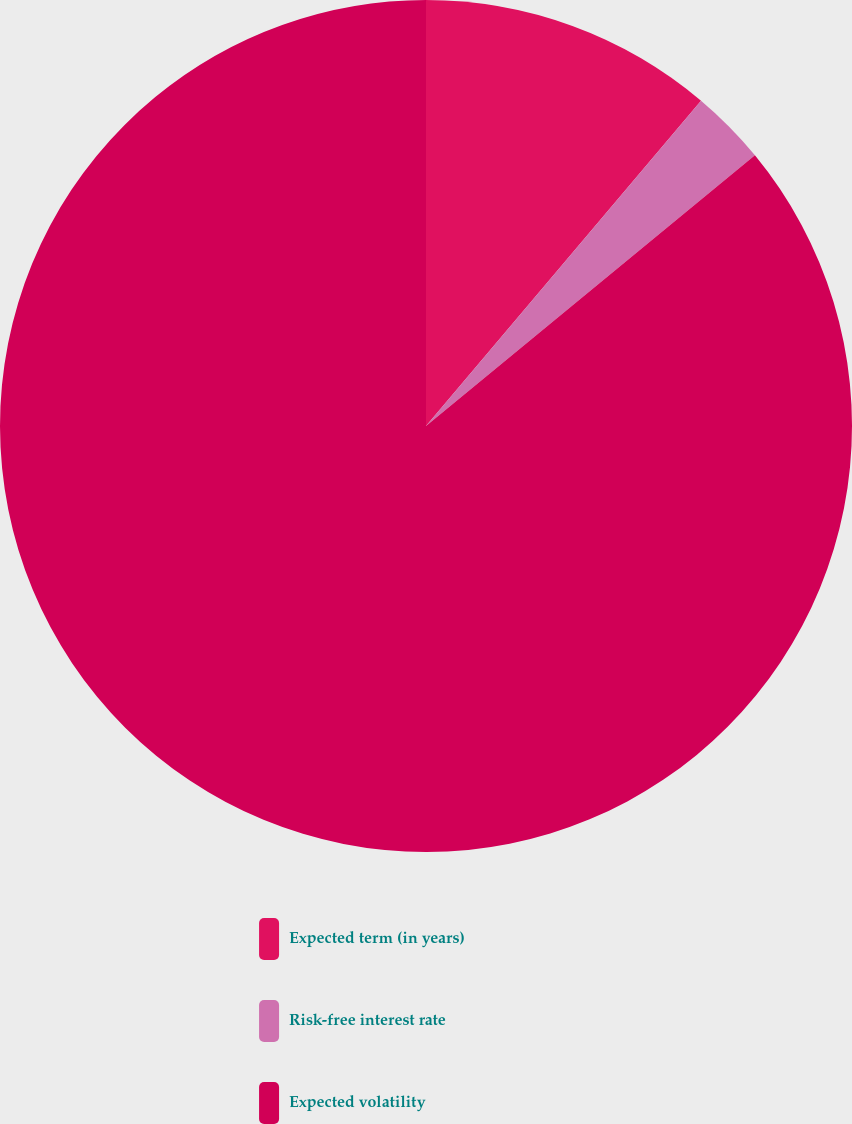Convert chart to OTSL. <chart><loc_0><loc_0><loc_500><loc_500><pie_chart><fcel>Expected term (in years)<fcel>Risk-free interest rate<fcel>Expected volatility<nl><fcel>11.17%<fcel>2.87%<fcel>85.96%<nl></chart> 